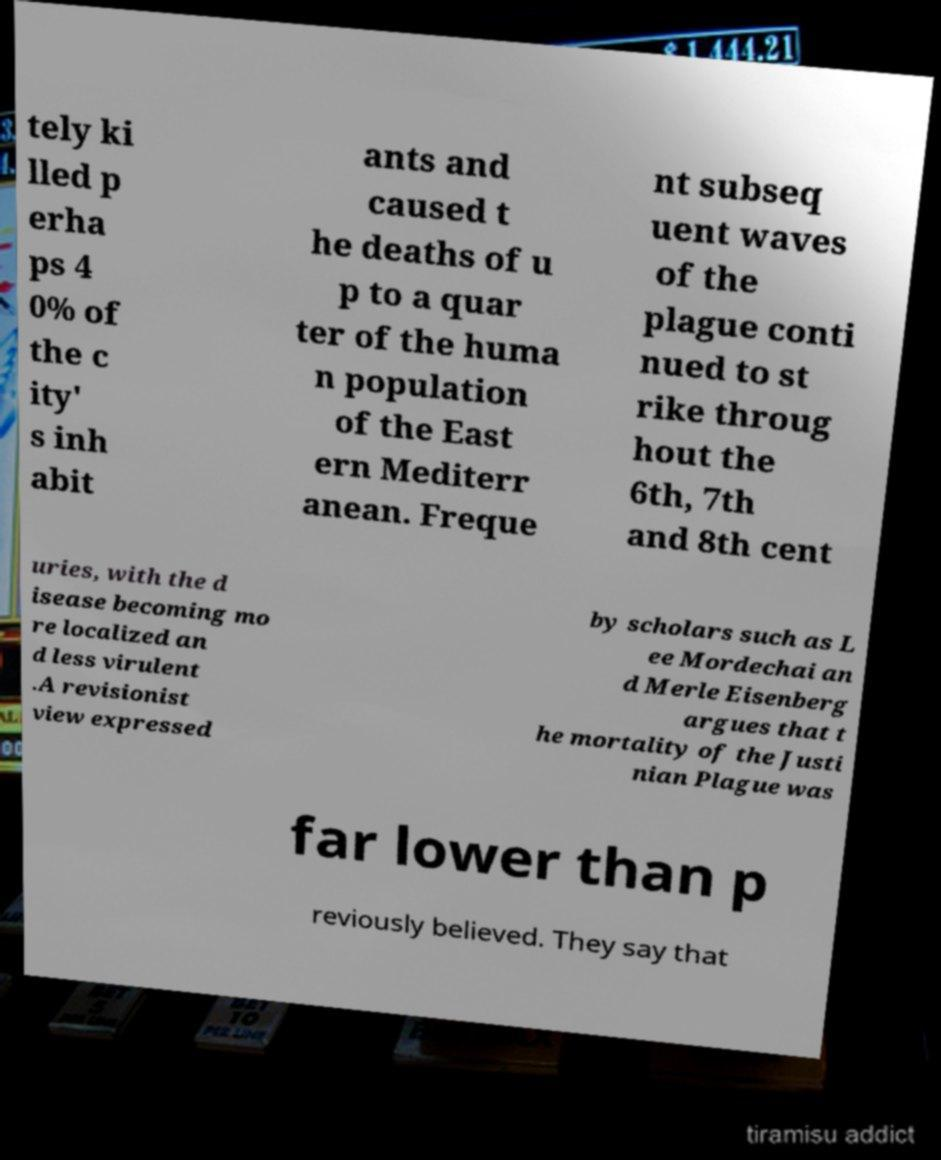For documentation purposes, I need the text within this image transcribed. Could you provide that? tely ki lled p erha ps 4 0% of the c ity' s inh abit ants and caused t he deaths of u p to a quar ter of the huma n population of the East ern Mediterr anean. Freque nt subseq uent waves of the plague conti nued to st rike throug hout the 6th, 7th and 8th cent uries, with the d isease becoming mo re localized an d less virulent .A revisionist view expressed by scholars such as L ee Mordechai an d Merle Eisenberg argues that t he mortality of the Justi nian Plague was far lower than p reviously believed. They say that 